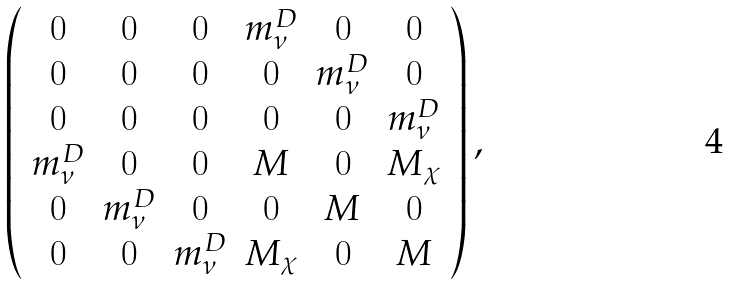<formula> <loc_0><loc_0><loc_500><loc_500>\left ( \begin{array} { c c c c c c } 0 & 0 & 0 & m _ { \nu } ^ { D } & 0 & 0 \\ 0 & 0 & 0 & 0 & m _ { \nu } ^ { D } & 0 \\ 0 & 0 & 0 & 0 & 0 & m _ { \nu } ^ { D } \\ m _ { \nu } ^ { D } & 0 & 0 & M & 0 & M _ { \chi } \\ 0 & m _ { \nu } ^ { D } & 0 & 0 & M & 0 \\ 0 & 0 & m _ { \nu } ^ { D } & M _ { \chi } & 0 & M \end{array} \right ) ,</formula> 